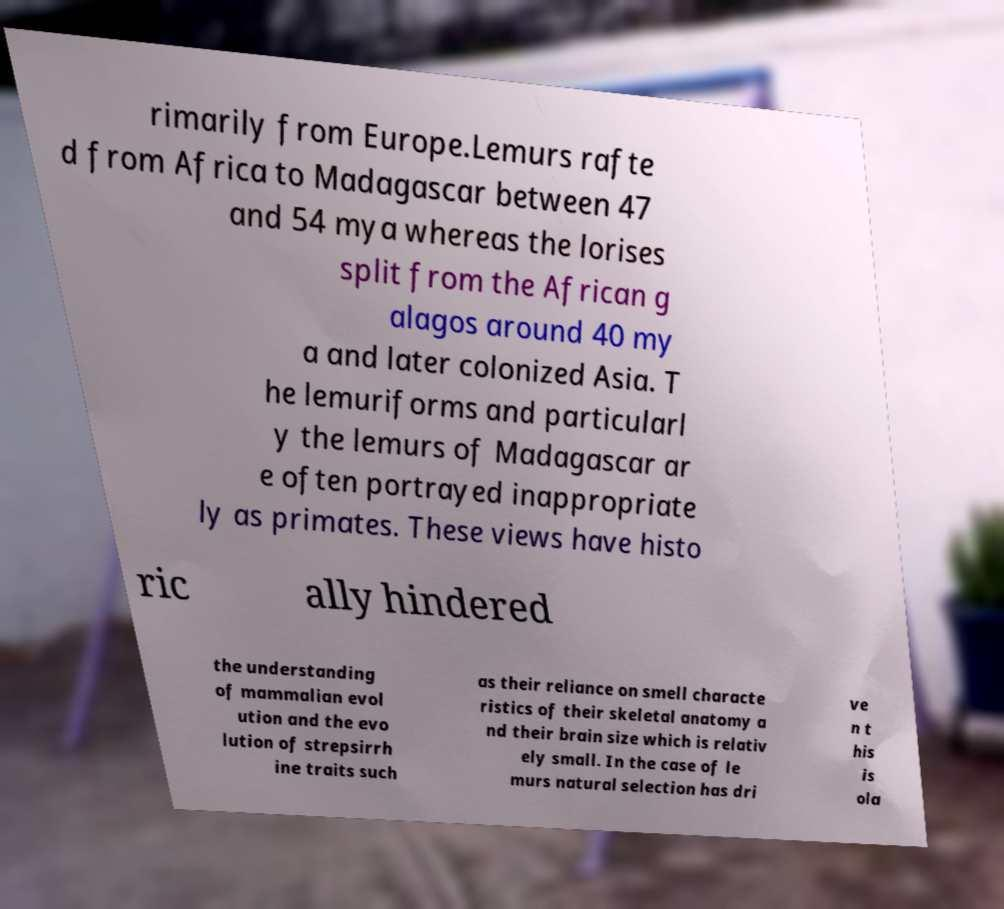Can you read and provide the text displayed in the image?This photo seems to have some interesting text. Can you extract and type it out for me? rimarily from Europe.Lemurs rafte d from Africa to Madagascar between 47 and 54 mya whereas the lorises split from the African g alagos around 40 my a and later colonized Asia. T he lemuriforms and particularl y the lemurs of Madagascar ar e often portrayed inappropriate ly as primates. These views have histo ric ally hindered the understanding of mammalian evol ution and the evo lution of strepsirrh ine traits such as their reliance on smell characte ristics of their skeletal anatomy a nd their brain size which is relativ ely small. In the case of le murs natural selection has dri ve n t his is ola 